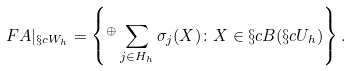<formula> <loc_0><loc_0><loc_500><loc_500>\ F { A } | _ { \S c { W } _ { h } } = \left \{ { ^ { \oplus } } \sum _ { j \in H _ { h } } \sigma _ { j } ( X ) \colon X \in \S c { B } ( \S c { U } _ { h } ) \right \} .</formula> 